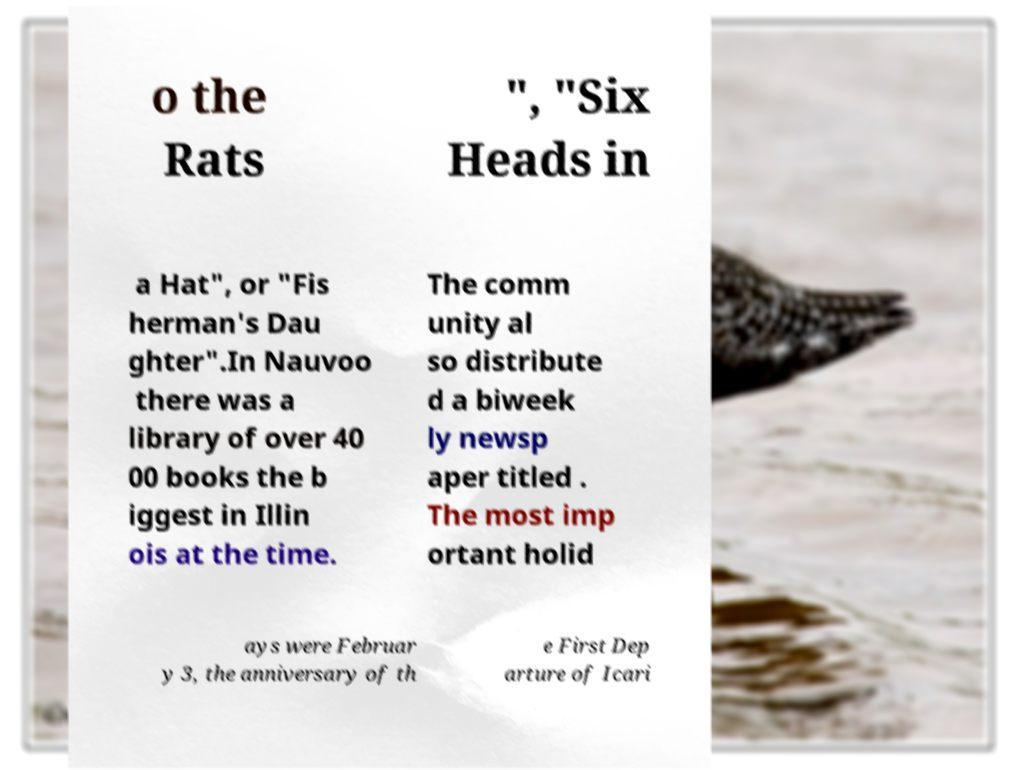Could you assist in decoding the text presented in this image and type it out clearly? o the Rats ", "Six Heads in a Hat", or "Fis herman's Dau ghter".In Nauvoo there was a library of over 40 00 books the b iggest in Illin ois at the time. The comm unity al so distribute d a biweek ly newsp aper titled . The most imp ortant holid ays were Februar y 3, the anniversary of th e First Dep arture of Icari 